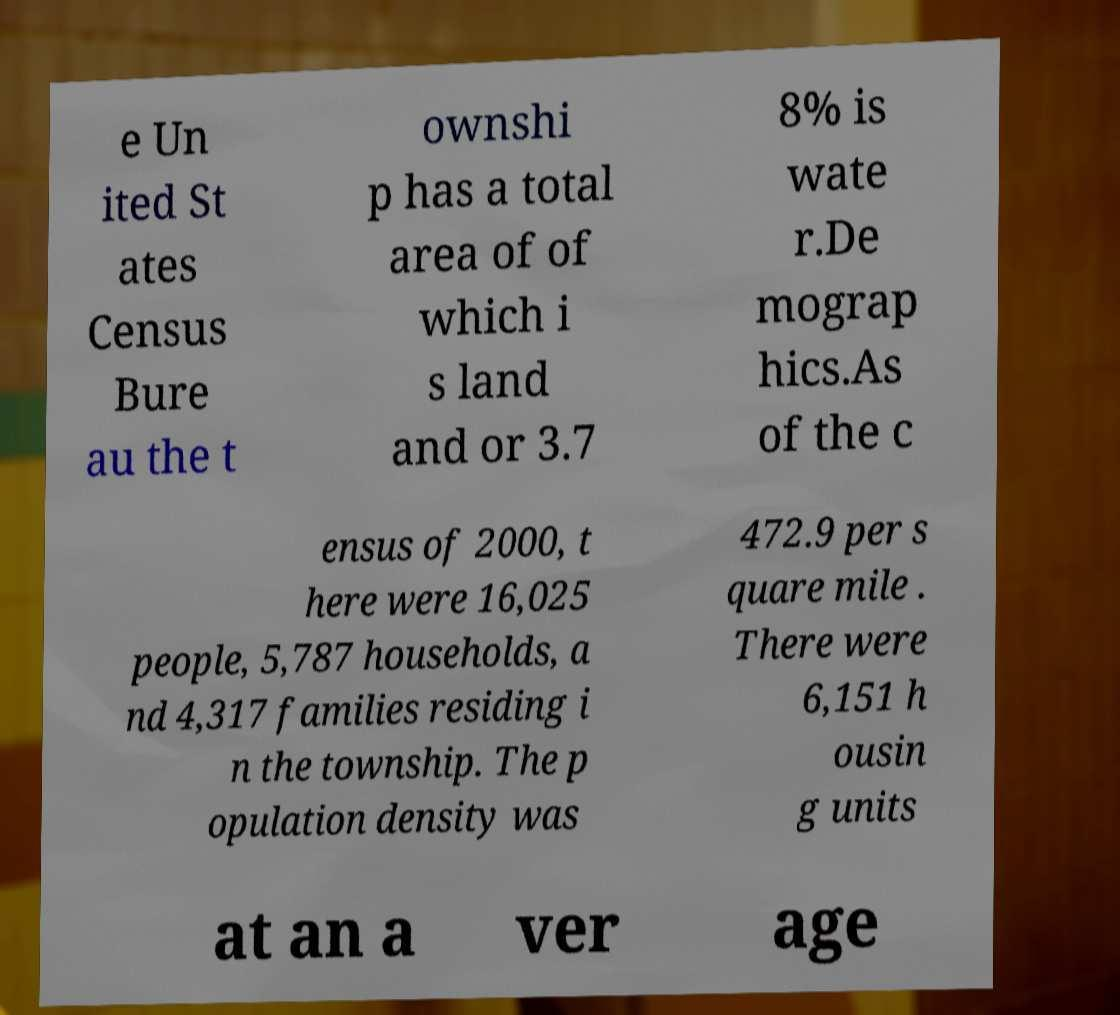For documentation purposes, I need the text within this image transcribed. Could you provide that? e Un ited St ates Census Bure au the t ownshi p has a total area of of which i s land and or 3.7 8% is wate r.De mograp hics.As of the c ensus of 2000, t here were 16,025 people, 5,787 households, a nd 4,317 families residing i n the township. The p opulation density was 472.9 per s quare mile . There were 6,151 h ousin g units at an a ver age 